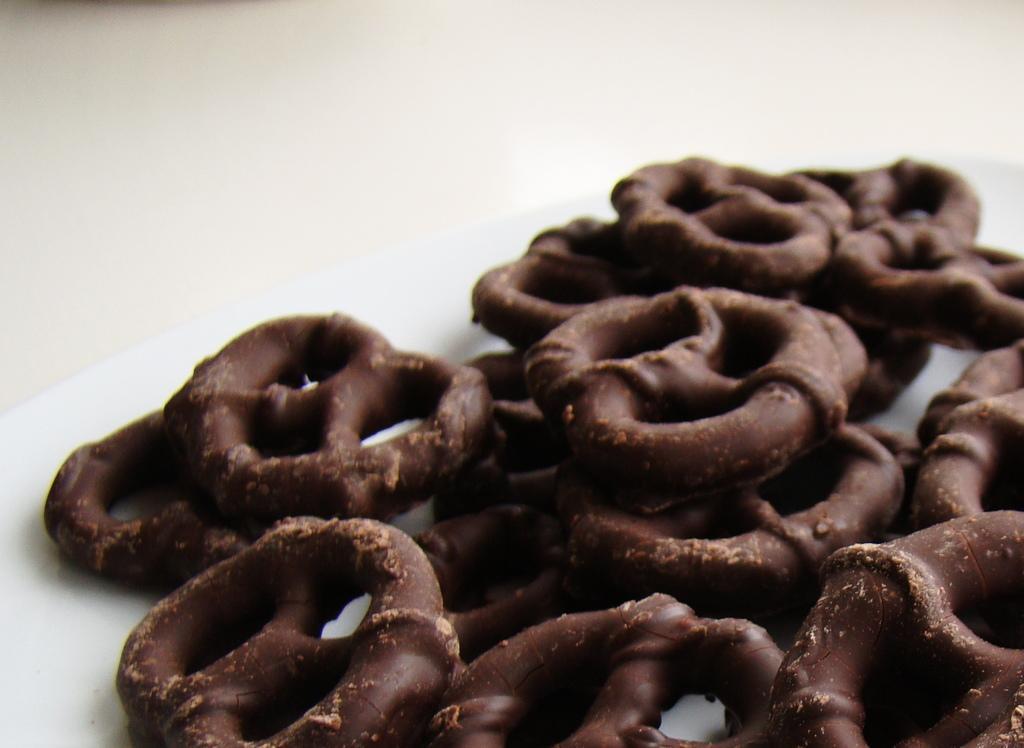Please provide a concise description of this image. In this image we can see some baked food placed on the surface. 